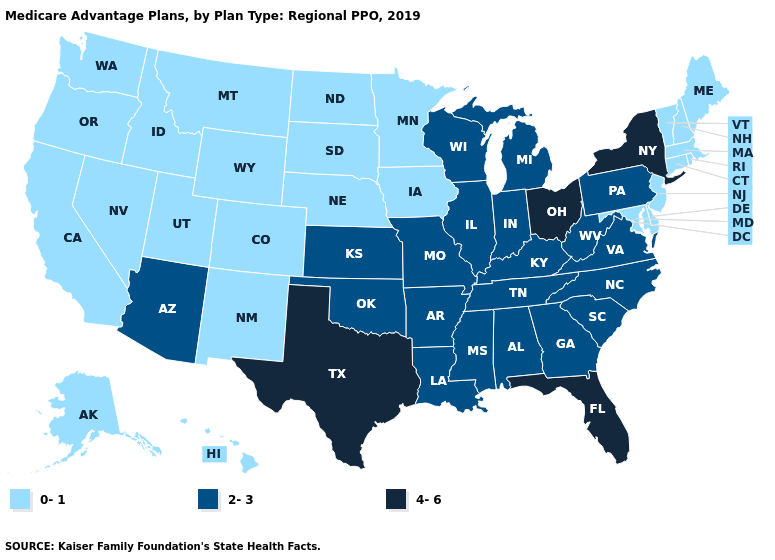What is the value of Rhode Island?
Quick response, please. 0-1. Does Idaho have a lower value than Connecticut?
Keep it brief. No. What is the highest value in states that border Utah?
Quick response, please. 2-3. Among the states that border Iowa , which have the highest value?
Short answer required. Illinois, Missouri, Wisconsin. What is the value of Arizona?
Give a very brief answer. 2-3. Among the states that border Arkansas , which have the highest value?
Answer briefly. Texas. What is the highest value in the MidWest ?
Write a very short answer. 4-6. Name the states that have a value in the range 2-3?
Be succinct. Alabama, Arizona, Arkansas, Georgia, Illinois, Indiana, Kansas, Kentucky, Louisiana, Michigan, Mississippi, Missouri, North Carolina, Oklahoma, Pennsylvania, South Carolina, Tennessee, Virginia, West Virginia, Wisconsin. What is the highest value in states that border North Dakota?
Answer briefly. 0-1. Which states hav the highest value in the South?
Short answer required. Florida, Texas. Which states have the lowest value in the USA?
Quick response, please. Alaska, California, Colorado, Connecticut, Delaware, Hawaii, Idaho, Iowa, Maine, Maryland, Massachusetts, Minnesota, Montana, Nebraska, Nevada, New Hampshire, New Jersey, New Mexico, North Dakota, Oregon, Rhode Island, South Dakota, Utah, Vermont, Washington, Wyoming. Which states have the lowest value in the MidWest?
Quick response, please. Iowa, Minnesota, Nebraska, North Dakota, South Dakota. What is the value of Nebraska?
Answer briefly. 0-1. Which states have the lowest value in the USA?
Keep it brief. Alaska, California, Colorado, Connecticut, Delaware, Hawaii, Idaho, Iowa, Maine, Maryland, Massachusetts, Minnesota, Montana, Nebraska, Nevada, New Hampshire, New Jersey, New Mexico, North Dakota, Oregon, Rhode Island, South Dakota, Utah, Vermont, Washington, Wyoming. Is the legend a continuous bar?
Keep it brief. No. 